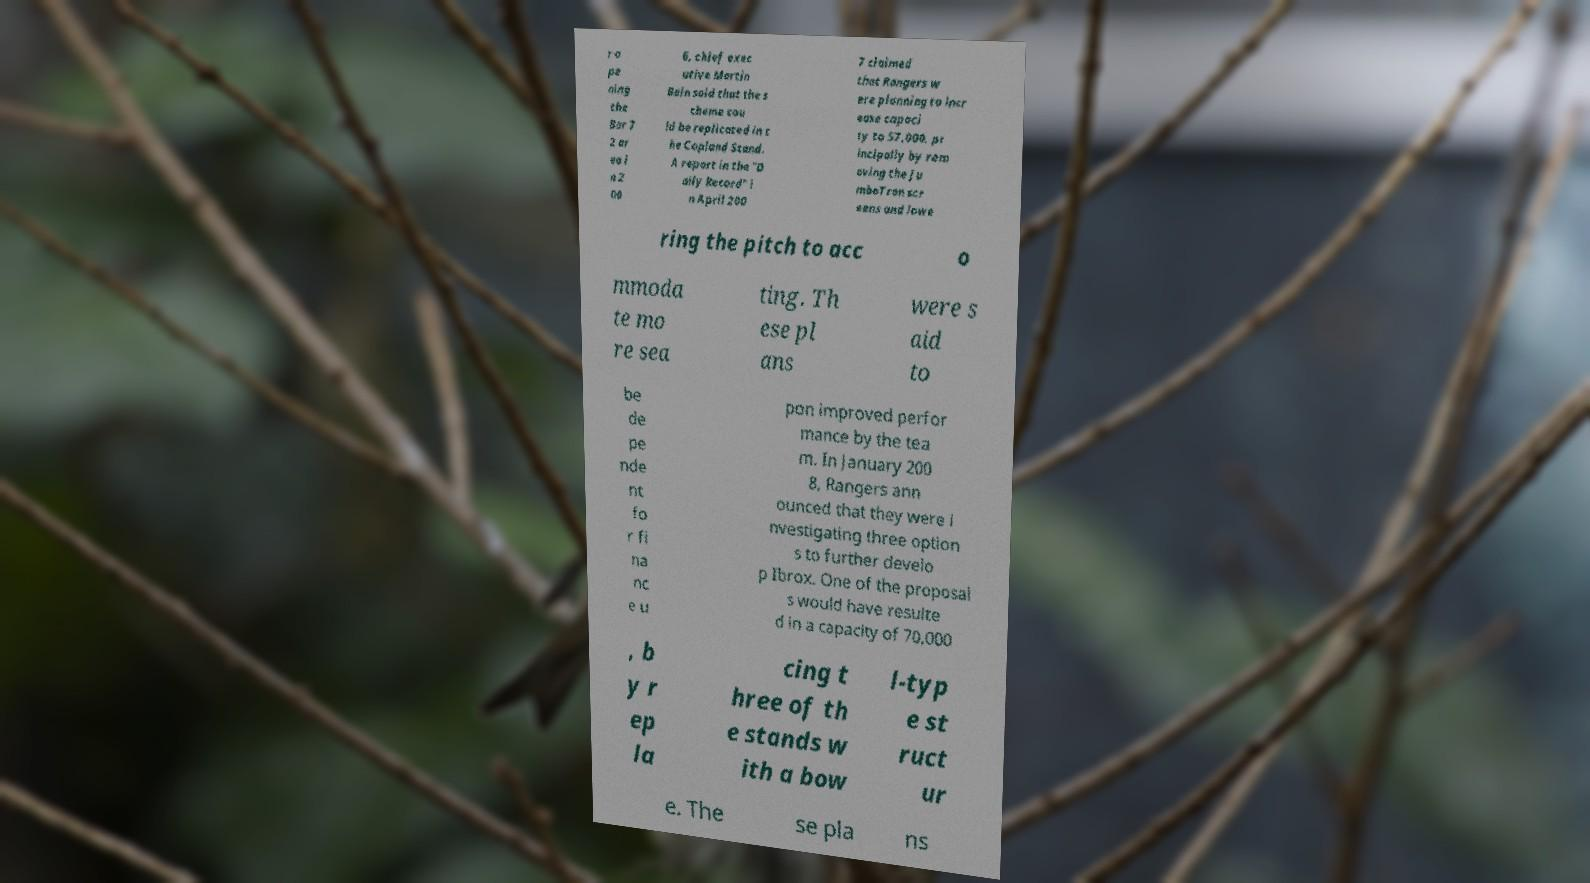What messages or text are displayed in this image? I need them in a readable, typed format. r o pe ning the Bar 7 2 ar ea i n 2 00 6, chief exec utive Martin Bain said that the s cheme cou ld be replicated in t he Copland Stand. A report in the "D aily Record" i n April 200 7 claimed that Rangers w ere planning to incr ease capaci ty to 57,000, pr incipally by rem oving the Ju mboTron scr eens and lowe ring the pitch to acc o mmoda te mo re sea ting. Th ese pl ans were s aid to be de pe nde nt fo r fi na nc e u pon improved perfor mance by the tea m. In January 200 8, Rangers ann ounced that they were i nvestigating three option s to further develo p Ibrox. One of the proposal s would have resulte d in a capacity of 70,000 , b y r ep la cing t hree of th e stands w ith a bow l-typ e st ruct ur e. The se pla ns 